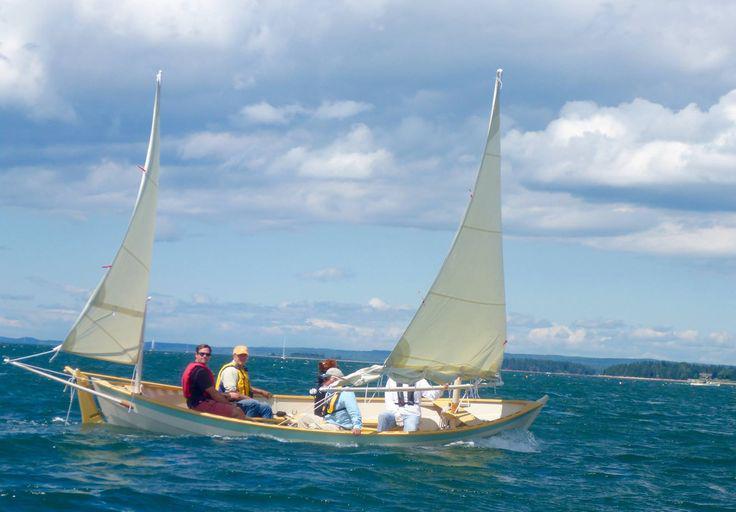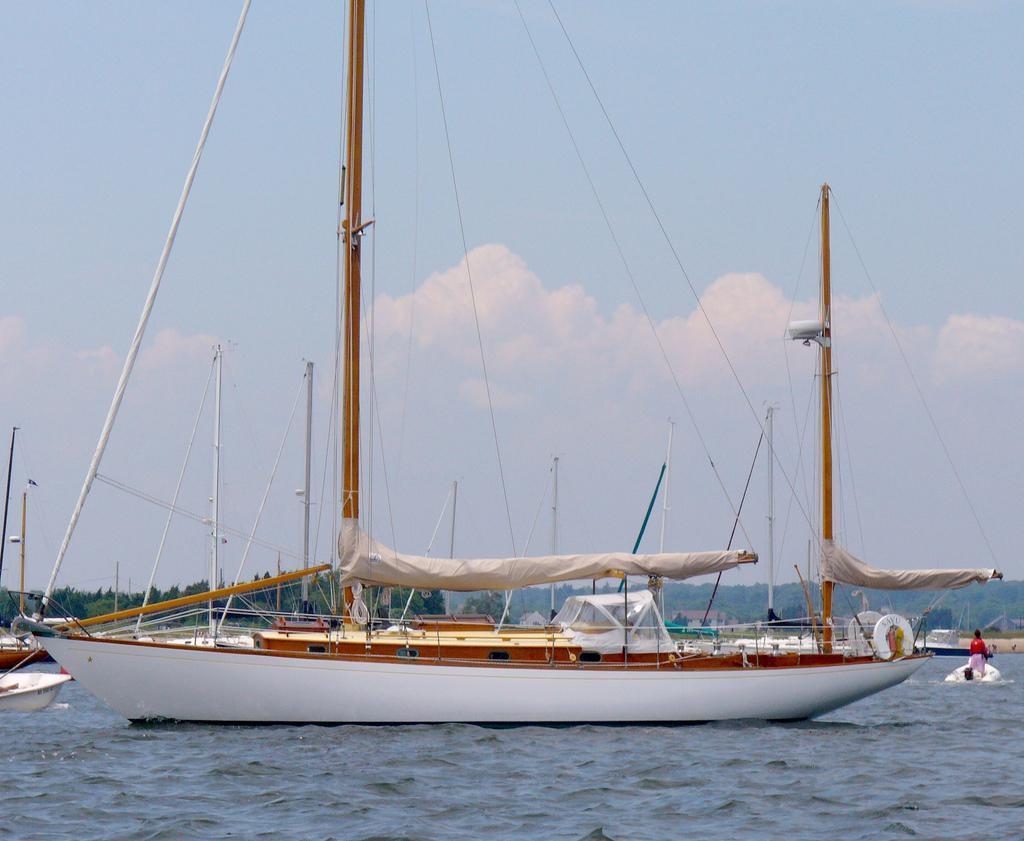The first image is the image on the left, the second image is the image on the right. For the images displayed, is the sentence "People are in two sailboats in the water in one of the images." factually correct? Answer yes or no. No. The first image is the image on the left, the second image is the image on the right. Assess this claim about the two images: "One image shows at least one sailboat with unfurled sails, and the other image shows a boat with furled sails that is not next to a dock.". Correct or not? Answer yes or no. Yes. 